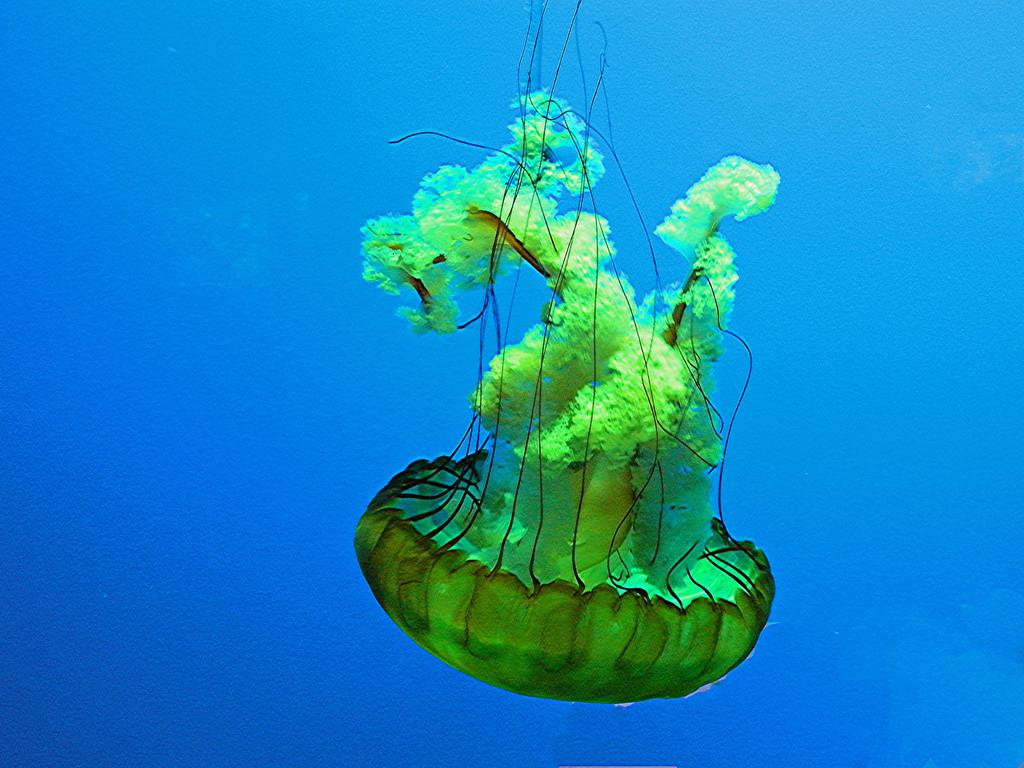What type of animal is in the image? There is a jellyfish in the image. Where is the jellyfish located? The jellyfish is in the water. What type of beast is holding a gun in the image? There is no beast or gun present in the image; it features a jellyfish in the water. What type of plough is visible in the image? There is no plough present in the image; it features a jellyfish in the water. 